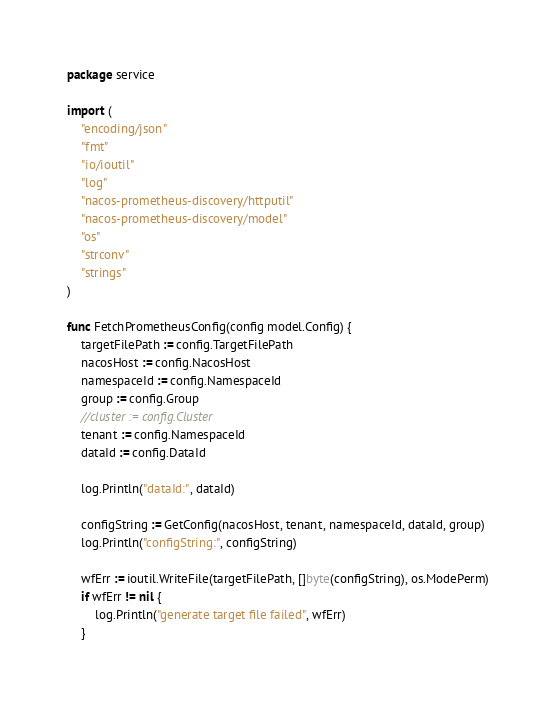<code> <loc_0><loc_0><loc_500><loc_500><_Go_>package service

import (
	"encoding/json"
	"fmt"
	"io/ioutil"
	"log"
	"nacos-prometheus-discovery/httputil"
	"nacos-prometheus-discovery/model"
	"os"
	"strconv"
	"strings"
)

func FetchPrometheusConfig(config model.Config) {
	targetFilePath := config.TargetFilePath
	nacosHost := config.NacosHost
	namespaceId := config.NamespaceId
	group := config.Group
	//cluster := config.Cluster
	tenant := config.NamespaceId
	dataId := config.DataId

	log.Println("dataId:", dataId)

	configString := GetConfig(nacosHost, tenant, namespaceId, dataId, group)
	log.Println("configString:", configString)

	wfErr := ioutil.WriteFile(targetFilePath, []byte(configString), os.ModePerm)
	if wfErr != nil {
		log.Println("generate target file failed", wfErr)
	}</code> 